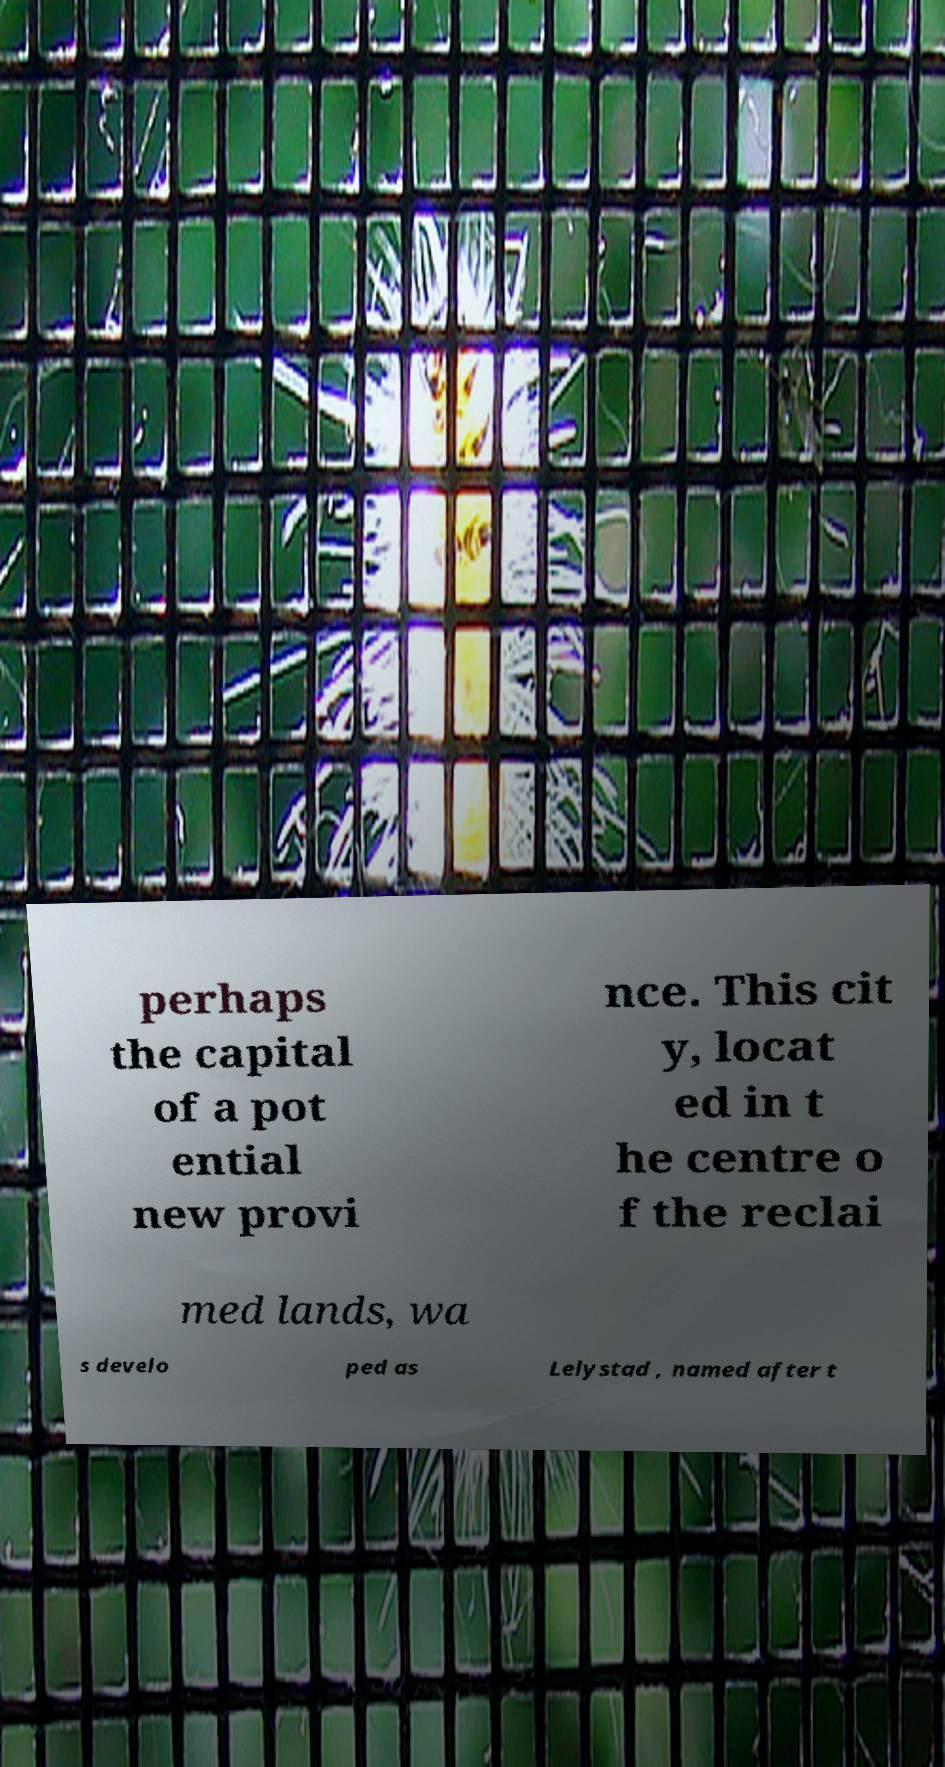What messages or text are displayed in this image? I need them in a readable, typed format. perhaps the capital of a pot ential new provi nce. This cit y, locat ed in t he centre o f the reclai med lands, wa s develo ped as Lelystad , named after t 